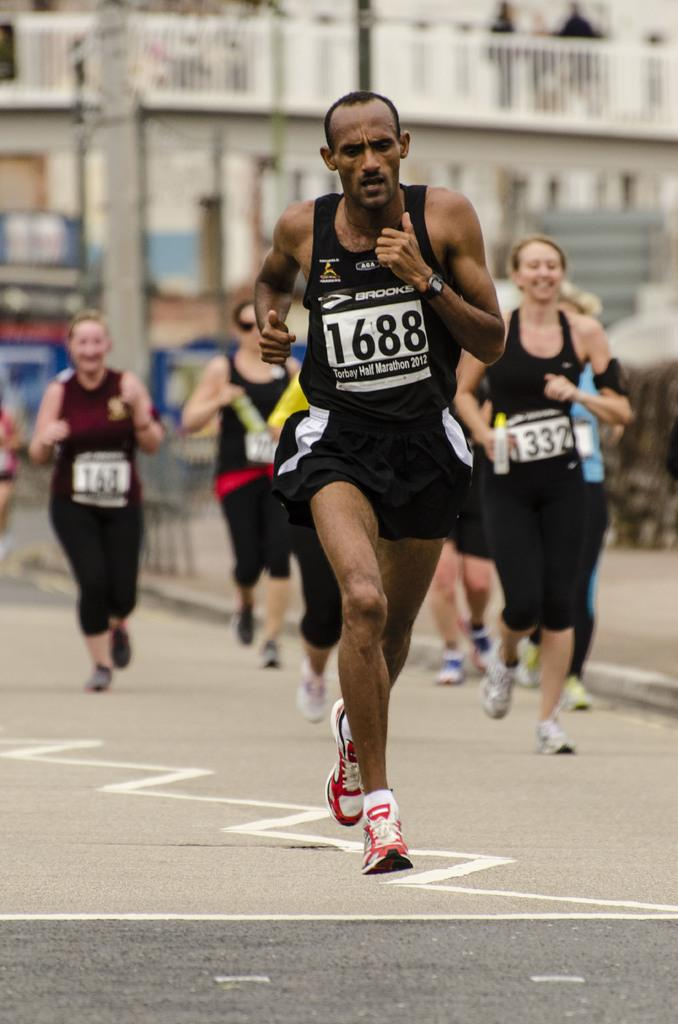How many people are in the image? There is a group of persons in the image. What are the persons wearing? The persons are wearing sports dress. What activity are the persons engaged in? The persons are running on a road. What can be seen in the background of the image? There are houses in the background of the image. How many ants can be seen carrying jelly on the road in the image? There are no ants or jelly present in the image. 